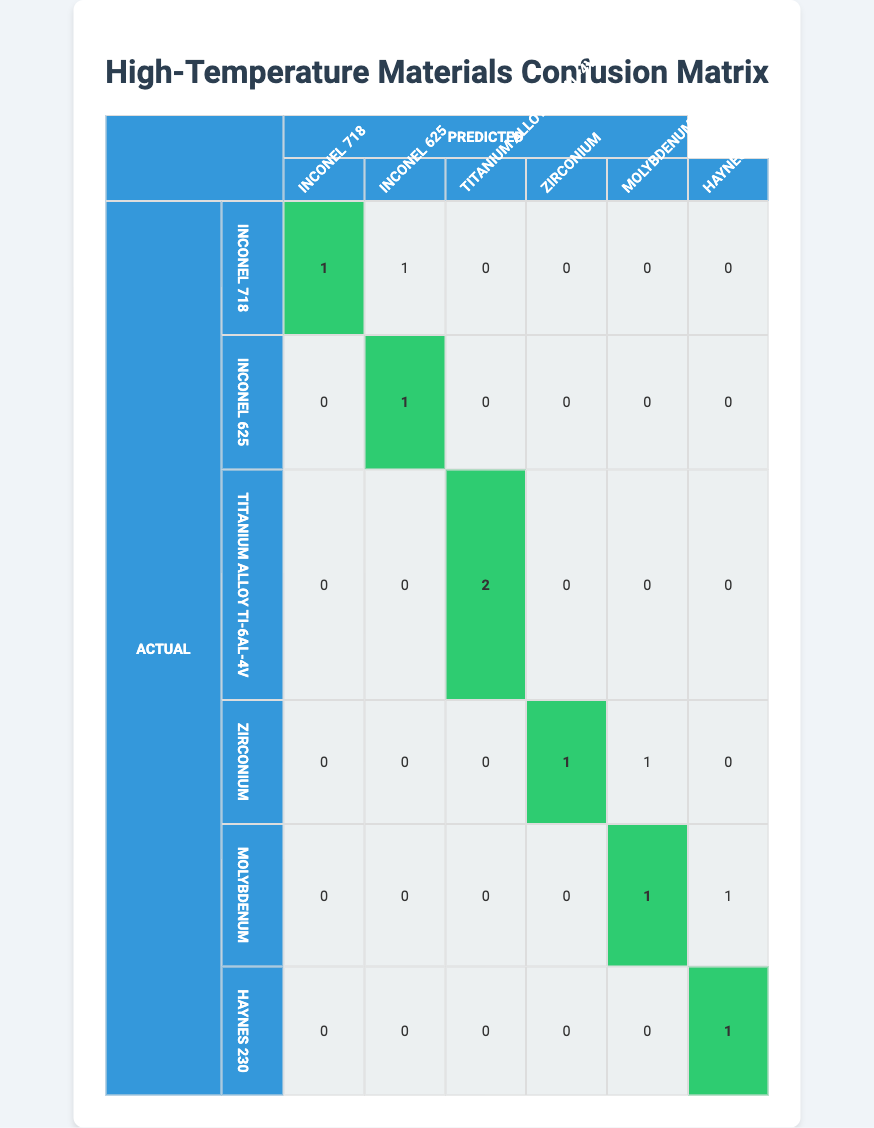What is the count of correctly predicted instances for Inconel 718? The diagonal value in the row for "Inconel 718" is 1, indicating that there is 1 correctly predicted instance for this material.
Answer: 1 How many instances were incorrectly predicted as Inconel 625? In the row for "Inconel 625," there are 0 instances in the "Inconel 718" column, thus there were no instances incorrectly predicted as Inconel 625.
Answer: 0 What is the total number of instances predicted as Molybdenum? To find the total predicted as Molybdenum, sum the values in the Molybdenum column, which are 0 (Inconel 718), 0 (Inconel 625), 0 (Titanium Alloy Ti-6Al-4V), 0 (Zirconium), 1 (Molybdenum), and 0 (Haynes 230), leading to a total of 2.
Answer: 2 Is Haynes 230 ever misclassified as another material? Looking at the row for Haynes 230, there are no values greater than 0 in any of the columns except for its own, indicating it is not misclassified as another material.
Answer: No How many instances of Titanium Alloy Ti-6Al-4V were correctly predicted? The diagonal value in the row for "Titanium Alloy Ti-6Al-4V" is 2, which means there are 2 instances of this material that were correctly predicted.
Answer: 2 What is the percentage of correct predictions for Zirconium? The correct predictions for Zirconium is 1 (from the diagonal), while there are 2 instances in total (1 correct + 1 incorrect); thus, (1/2)*100 = 50%.
Answer: 50% Which material had the highest number of incorrect predictions? By analyzing the rows, Molybdenum has 2 incorrect predictions (1 incorrectly predicted as Molybdenum and 1 incorrectly predicted as Haynes 230), the highest among all materials.
Answer: Molybdenum What is the total number of samples tested, and how may have been correctly predicted? The total number of samples is 10, and the sum of the diagonal entries gives us the total correct predictions, which is 5 (1 + 1 + 2 + 1 + 1).
Answer: 10 samples tested, 5 correctly predicted 